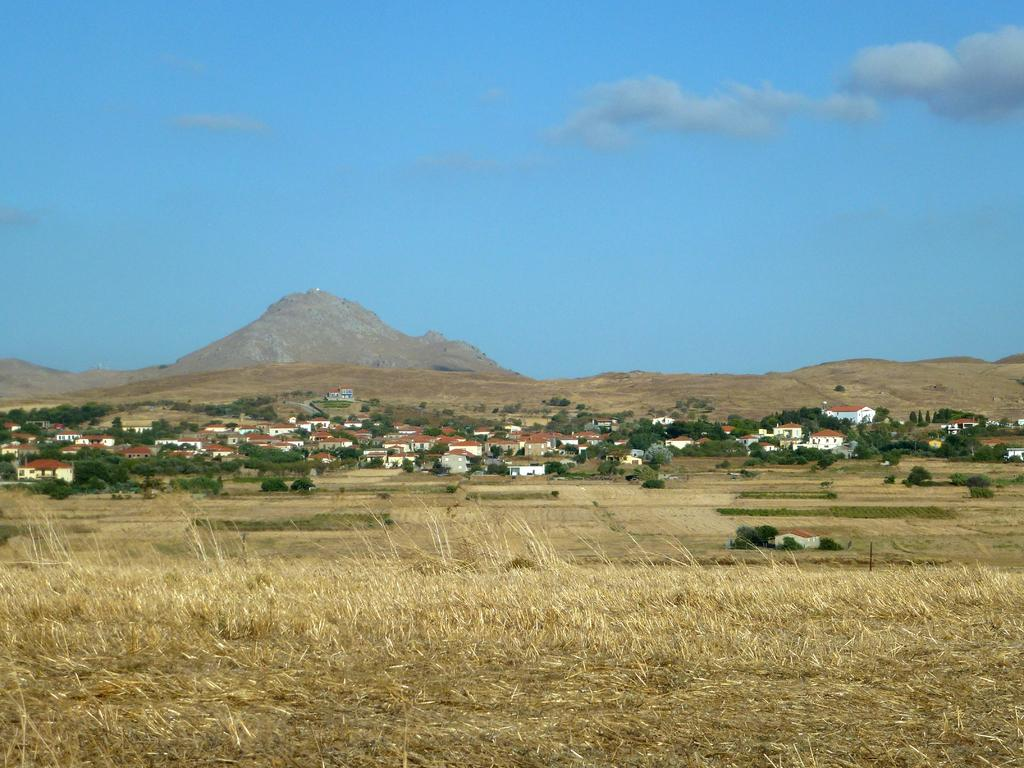What type of structures can be seen in the image? There are houses in the image. What type of vegetation is present in the image? There are trees and grass in the image. What can be seen in the background of the image? Hills and the sky are visible in the background of the image. What is the name of the art piece displayed on the hill in the image? There is no art piece displayed on the hill in the image. What is located in the middle of the image? The image does not have a specific focal point or object in the middle; it features a landscape with houses, trees, grass, hills, and the sky. 